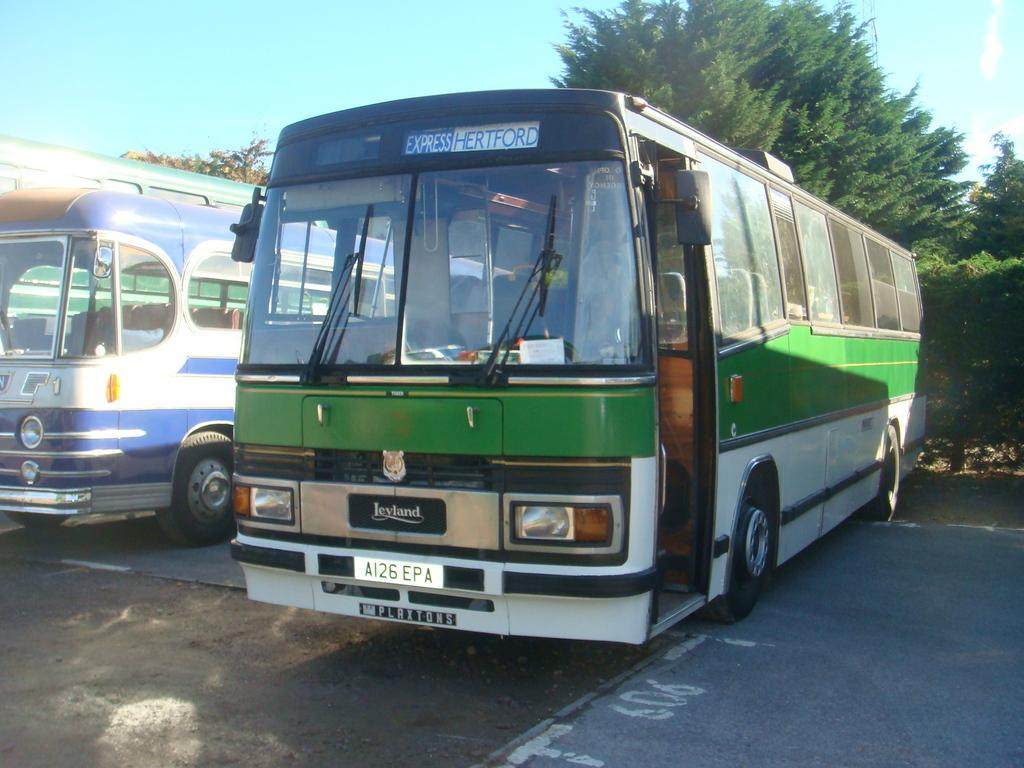<image>
Give a short and clear explanation of the subsequent image. An older parked city bus, showing it as an express to Hertford. 